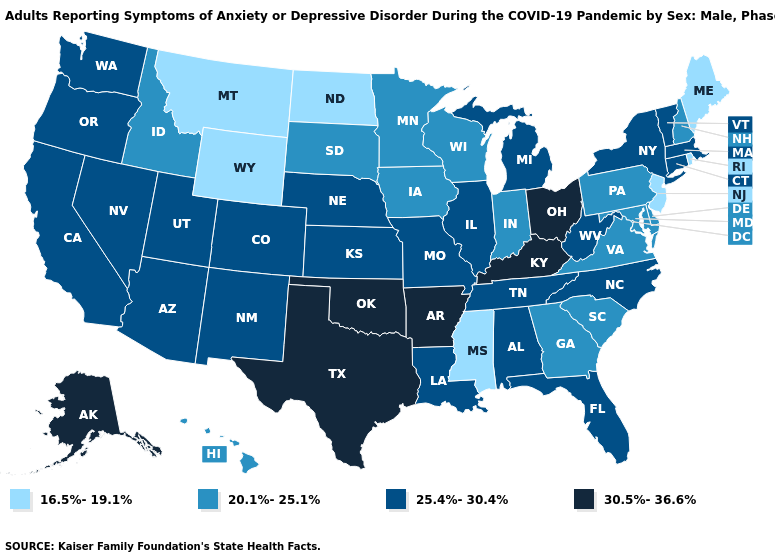Does the map have missing data?
Be succinct. No. What is the value of Minnesota?
Write a very short answer. 20.1%-25.1%. Name the states that have a value in the range 20.1%-25.1%?
Write a very short answer. Delaware, Georgia, Hawaii, Idaho, Indiana, Iowa, Maryland, Minnesota, New Hampshire, Pennsylvania, South Carolina, South Dakota, Virginia, Wisconsin. Which states hav the highest value in the South?
Answer briefly. Arkansas, Kentucky, Oklahoma, Texas. Which states have the highest value in the USA?
Quick response, please. Alaska, Arkansas, Kentucky, Ohio, Oklahoma, Texas. How many symbols are there in the legend?
Concise answer only. 4. Among the states that border Illinois , does Iowa have the highest value?
Concise answer only. No. What is the value of Alaska?
Concise answer only. 30.5%-36.6%. What is the value of New Hampshire?
Answer briefly. 20.1%-25.1%. What is the lowest value in the Northeast?
Write a very short answer. 16.5%-19.1%. What is the highest value in the Northeast ?
Write a very short answer. 25.4%-30.4%. How many symbols are there in the legend?
Write a very short answer. 4. Which states have the lowest value in the USA?
Short answer required. Maine, Mississippi, Montana, New Jersey, North Dakota, Rhode Island, Wyoming. Does the map have missing data?
Write a very short answer. No. Is the legend a continuous bar?
Quick response, please. No. 